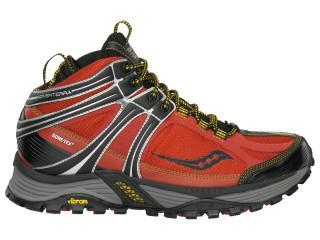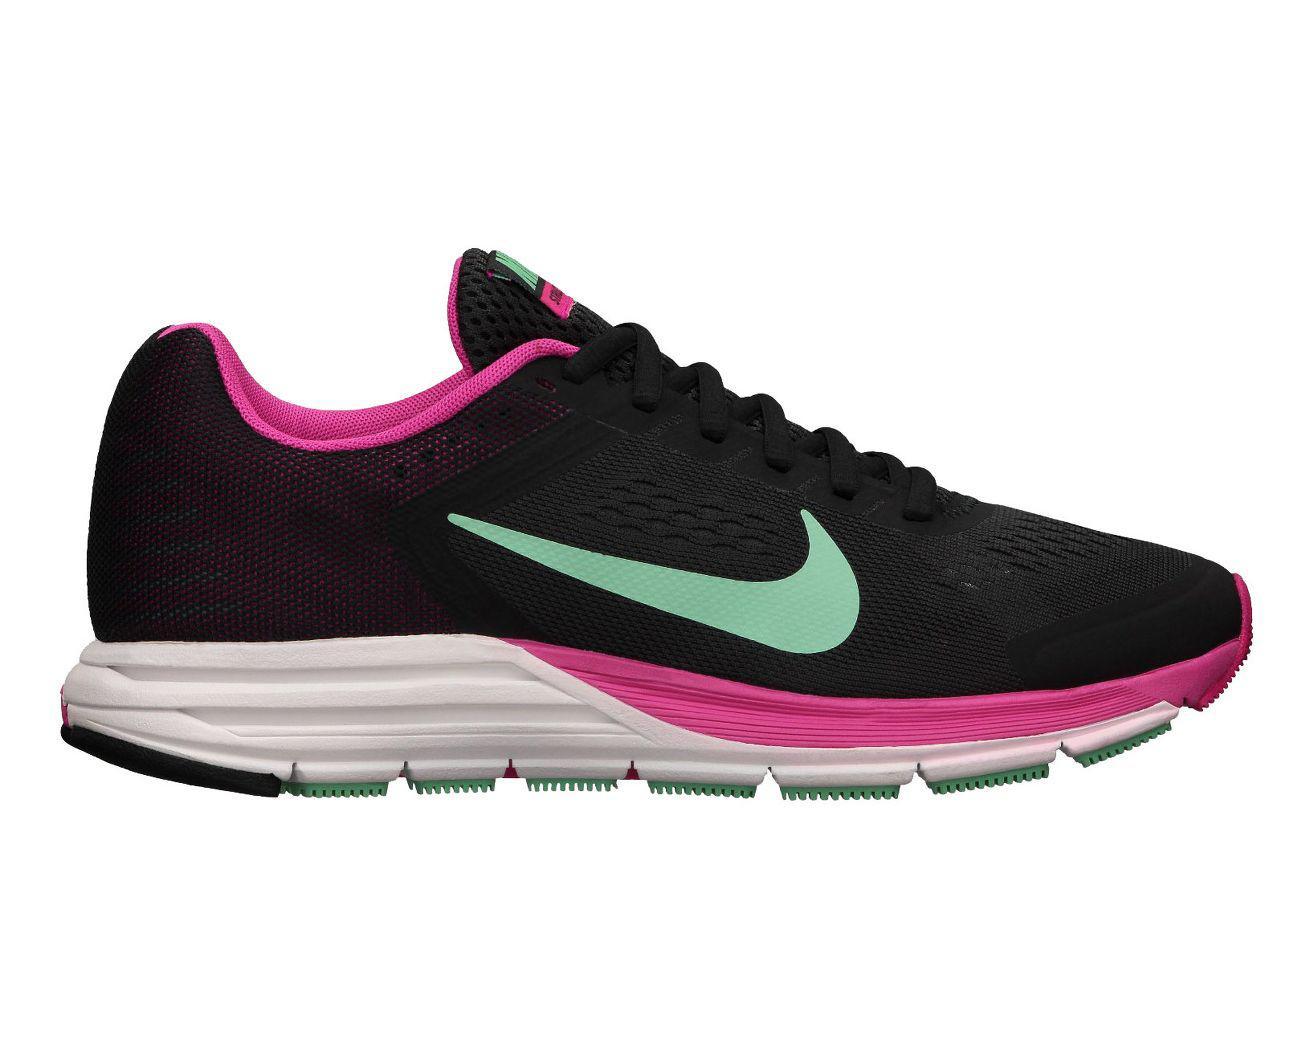The first image is the image on the left, the second image is the image on the right. Analyze the images presented: Is the assertion "Both shoes are pointing to the right." valid? Answer yes or no. Yes. The first image is the image on the left, the second image is the image on the right. Analyze the images presented: Is the assertion "There are atleast two shoes facing right" valid? Answer yes or no. Yes. 